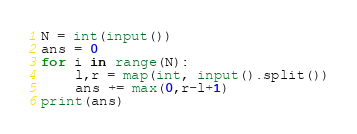<code> <loc_0><loc_0><loc_500><loc_500><_Python_>N = int(input())
ans = 0
for i in range(N):
    l,r = map(int, input().split())
    ans += max(0,r-l+1)
print(ans)
</code> 